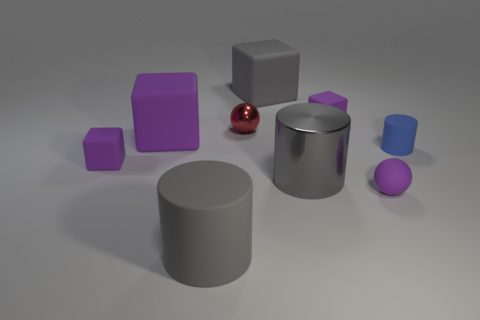What kind of lighting is used in this scene, and how does it affect the appearance of the objects? The lighting in this scene is diffuse and soft, coming from a direction that is not visible in the frame. It casts gentle shadows to the right of the objects, suggesting the light source is to the left. This even lighting reduces harsh shadows and allows the true colors and textures of the objects to be prominently displayed, enhancing their three-dimensional appearance without creating strong specular highlights.  Based on the lighting and shadows, can you tell where the light might be coming from? Based on the positioning and softness of the shadows, the light source appears to be to the left of the scene and possibly slightly above the objects. It's likely a large, soft light source, which evenly illuminates the objects and creates soft-edged shadows without any harsh or direct light. 